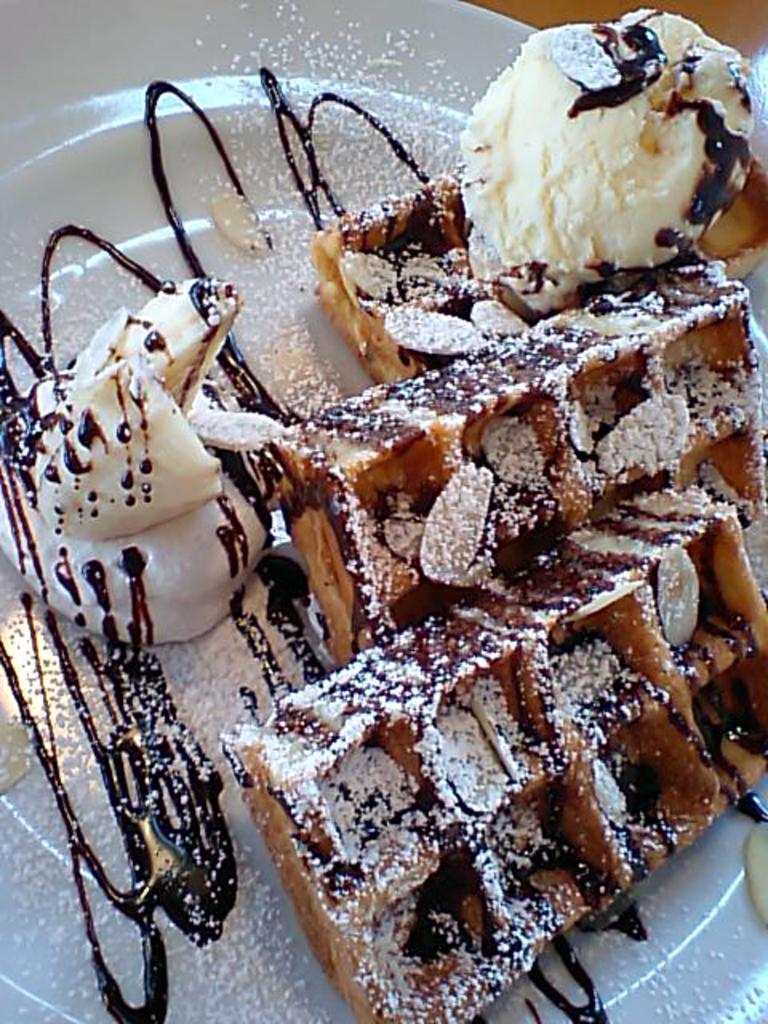What is the main piece of furniture in the image? There is a table in the image. What is placed on the table? On the table, there is a plate. What type of food is on the plate? On the plate, there are brownies, ice cream, and nuts. What type of birthday celebration is depicted in the image? There is no indication of a birthday celebration in the image; it only shows a table with a plate containing brownies, ice cream, and nuts. 